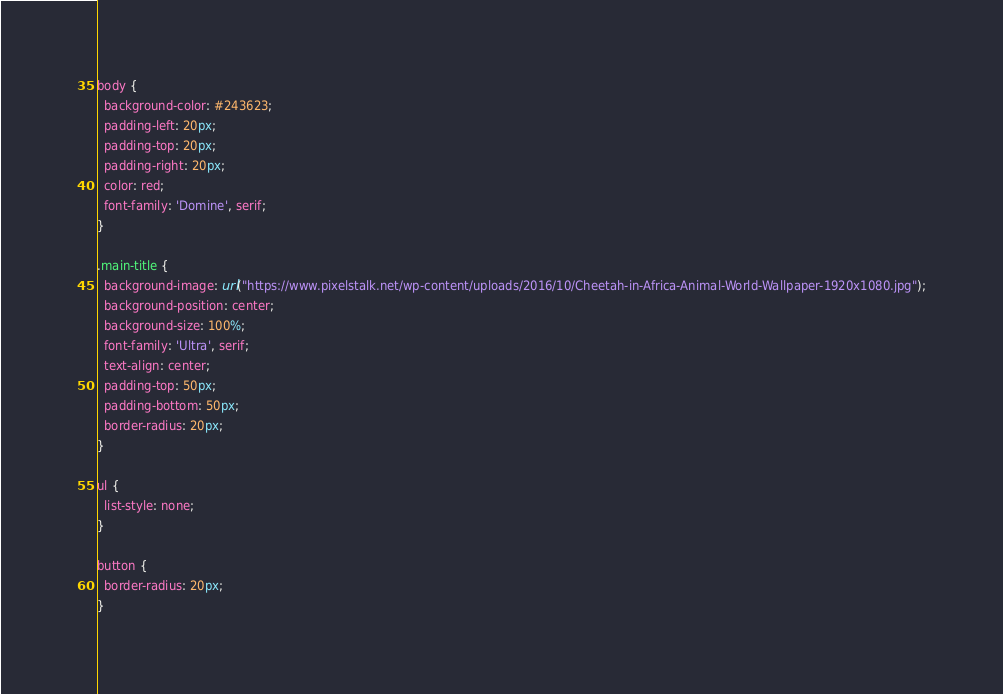<code> <loc_0><loc_0><loc_500><loc_500><_CSS_>body {
  background-color: #243623;
  padding-left: 20px;
  padding-top: 20px;
  padding-right: 20px;
  color: red;
  font-family: 'Domine', serif;
}

.main-title {
  background-image: url("https://www.pixelstalk.net/wp-content/uploads/2016/10/Cheetah-in-Africa-Animal-World-Wallpaper-1920x1080.jpg");
  background-position: center;
  background-size: 100%;
  font-family: 'Ultra', serif;
  text-align: center;
  padding-top: 50px;
  padding-bottom: 50px;
  border-radius: 20px;
}

ul {
  list-style: none;
}

button {
  border-radius: 20px;
}
</code> 